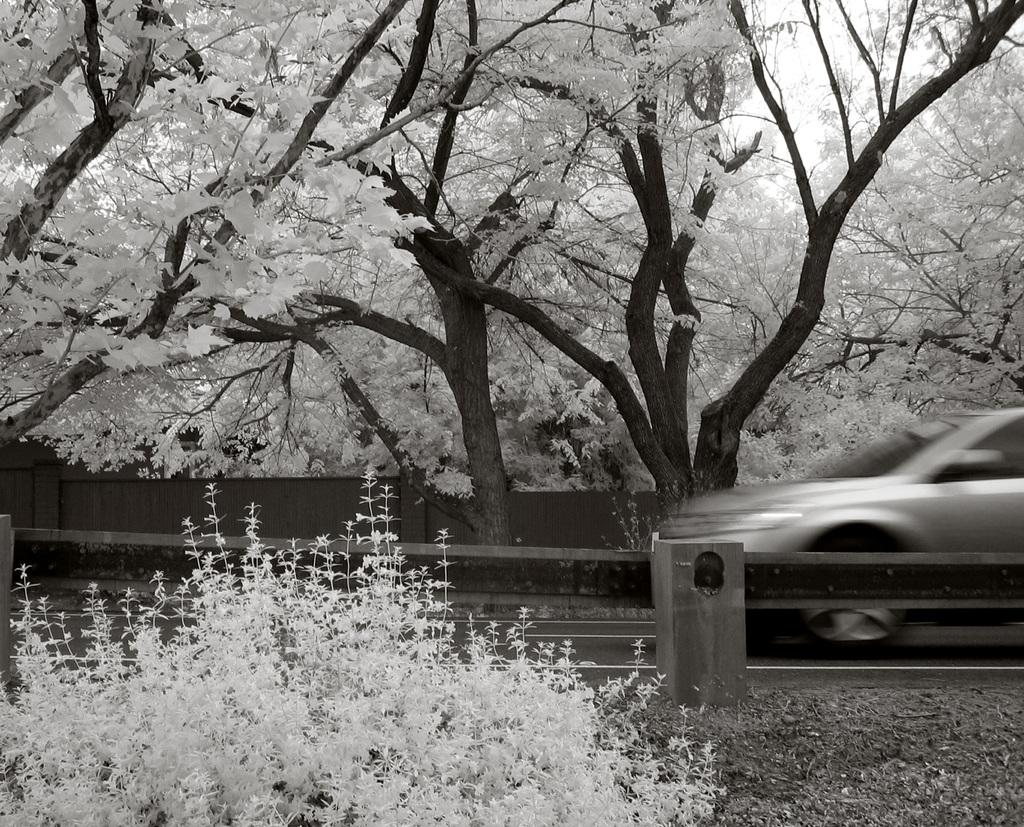What type of living organism can be seen in the image? There is a plant in the image. What is located on the road in the image? There is a car on the road in the image. What structure is present in the image? There is a railing in the image. What can be seen in the background of the image? There are trees in the background of the image. What color is the crayon used to draw the history of the plant in the image? There is no crayon or drawing of the plant's history present in the image. How many dolls are sitting on the railing in the image? There are no dolls present in the image. 